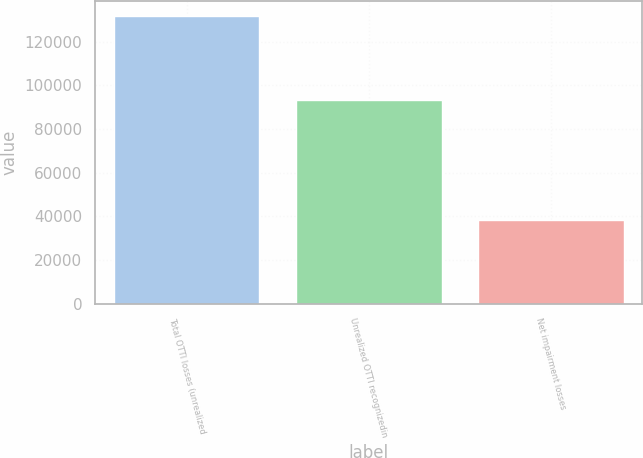<chart> <loc_0><loc_0><loc_500><loc_500><bar_chart><fcel>Total OTTI losses (unrealized<fcel>Unrealized OTTI recognizedin<fcel>Net impairment losses<nl><fcel>131902<fcel>93491<fcel>38411<nl></chart> 